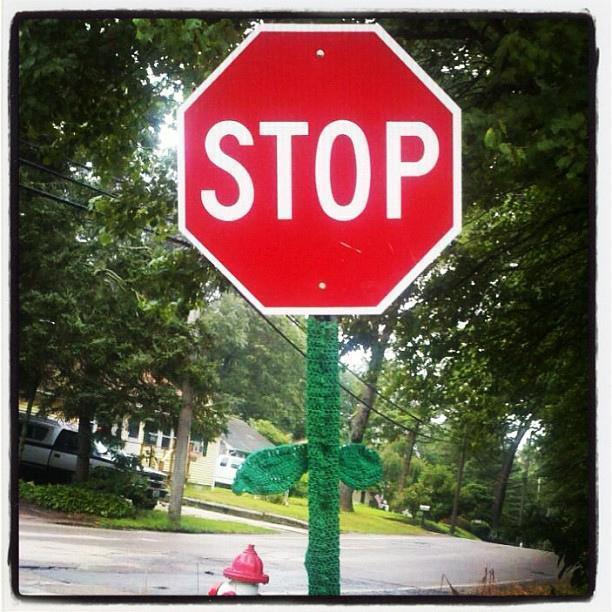How many vehicles are in the background?
Give a very brief answer. 1. How many people are wearing white shirt?
Give a very brief answer. 0. 